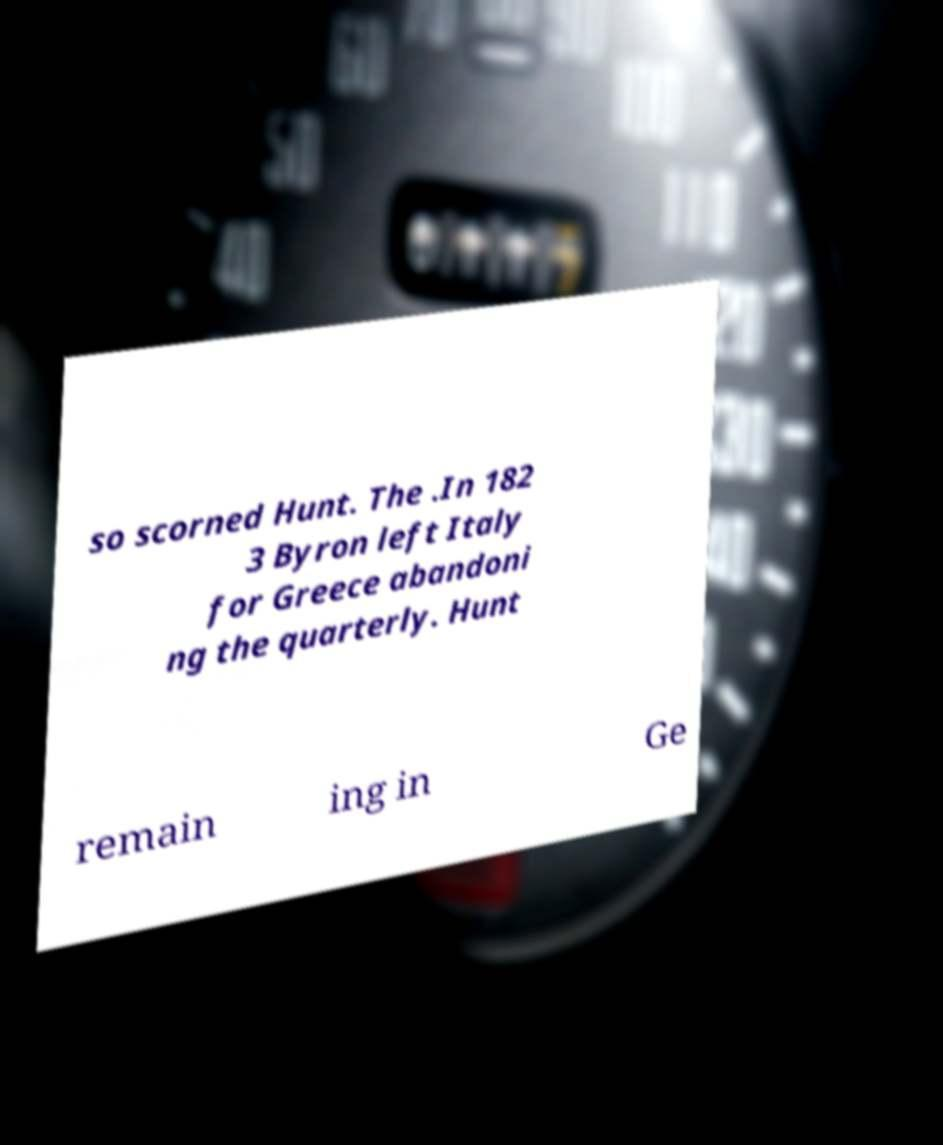I need the written content from this picture converted into text. Can you do that? so scorned Hunt. The .In 182 3 Byron left Italy for Greece abandoni ng the quarterly. Hunt remain ing in Ge 